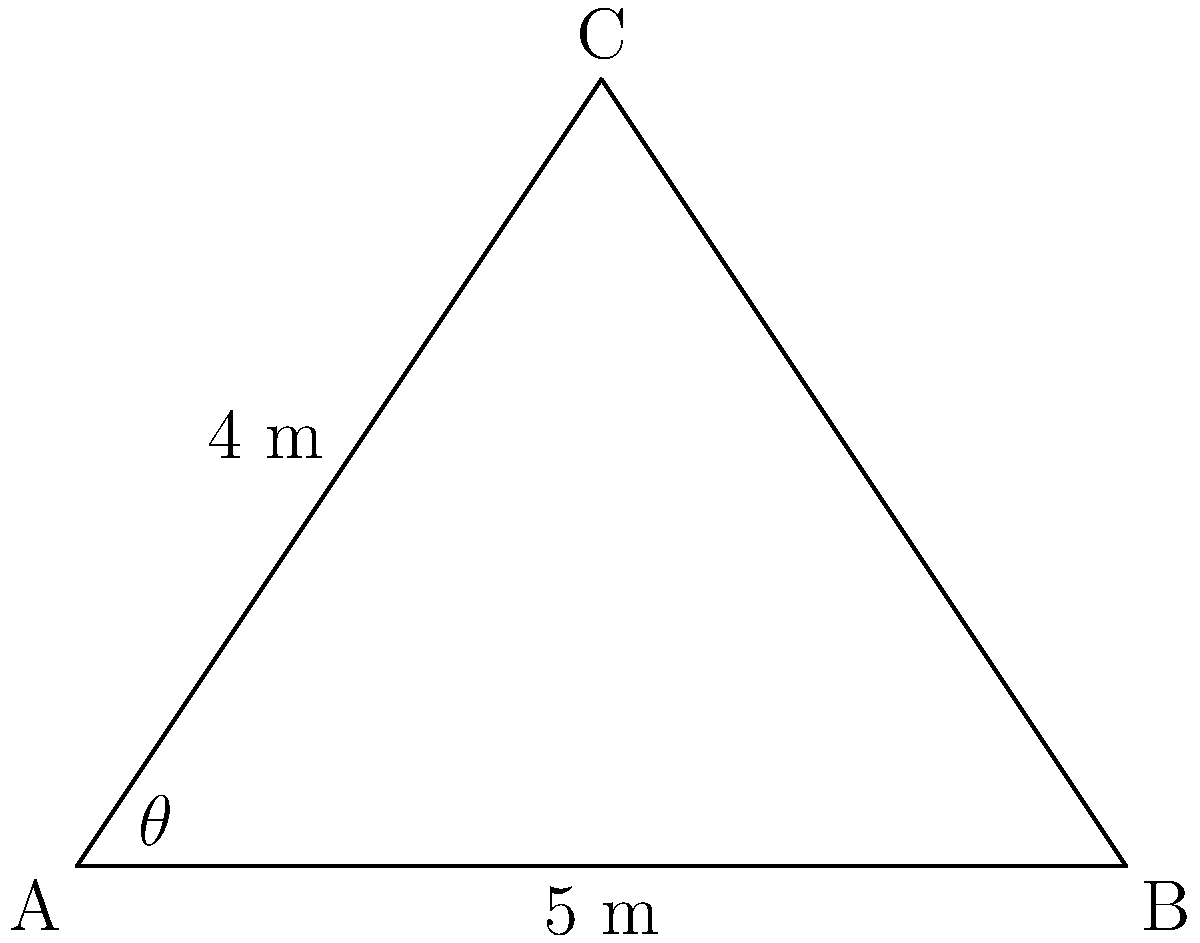For a retro music concert in Shanghai celebrating Hong Kong's golden era, you're designing a triangular banner. The banner's base is 5 meters, and one of its sides is 4 meters. The angle between these two sides is $\theta$. Calculate the area of the banner using the sine function. To find the area of the triangular banner, we can use the formula:

$$\text{Area} = \frac{1}{2} \times \text{base} \times \text{height}$$

We know the base is 5 meters, but we need to find the height using the sine function.

1) In a triangle, $\sin \theta = \frac{\text{opposite}}{\text{hypotenuse}}$

2) Here, the opposite side is the height (h) we're looking for, and the hypotenuse is the known side of 4 meters.

3) So, $\sin \theta = \frac{h}{4}$

4) We can rearrange this to: $h = 4 \sin \theta$

5) Now we can substitute this into our area formula:

   $$\text{Area} = \frac{1}{2} \times 5 \times (4 \sin \theta)$$

6) Simplifying:

   $$\text{Area} = 10 \sin \theta$$

Therefore, the area of the triangular banner is $10 \sin \theta$ square meters.
Answer: $10 \sin \theta$ m² 